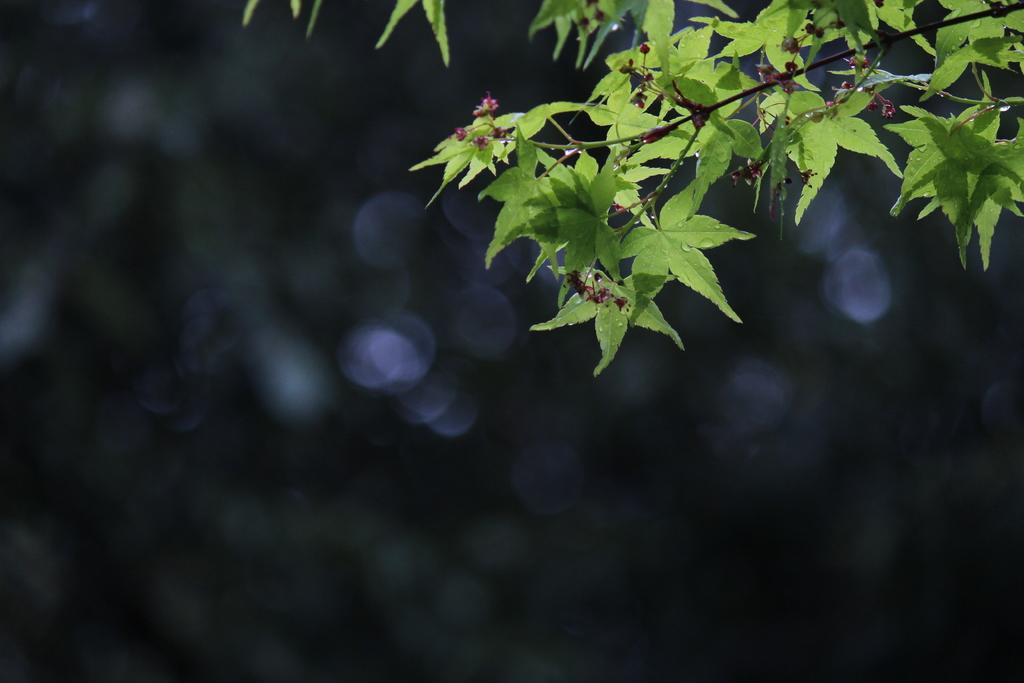What type of plant elements are visible in the image? There are stems with leaves in the image. What part of the plant is most visible at the top of the image? The top of the image contains leaves. How would you describe the background of the image? The background of the image is blurry. What is the purpose of the tray in the image? There is no tray present in the image. 